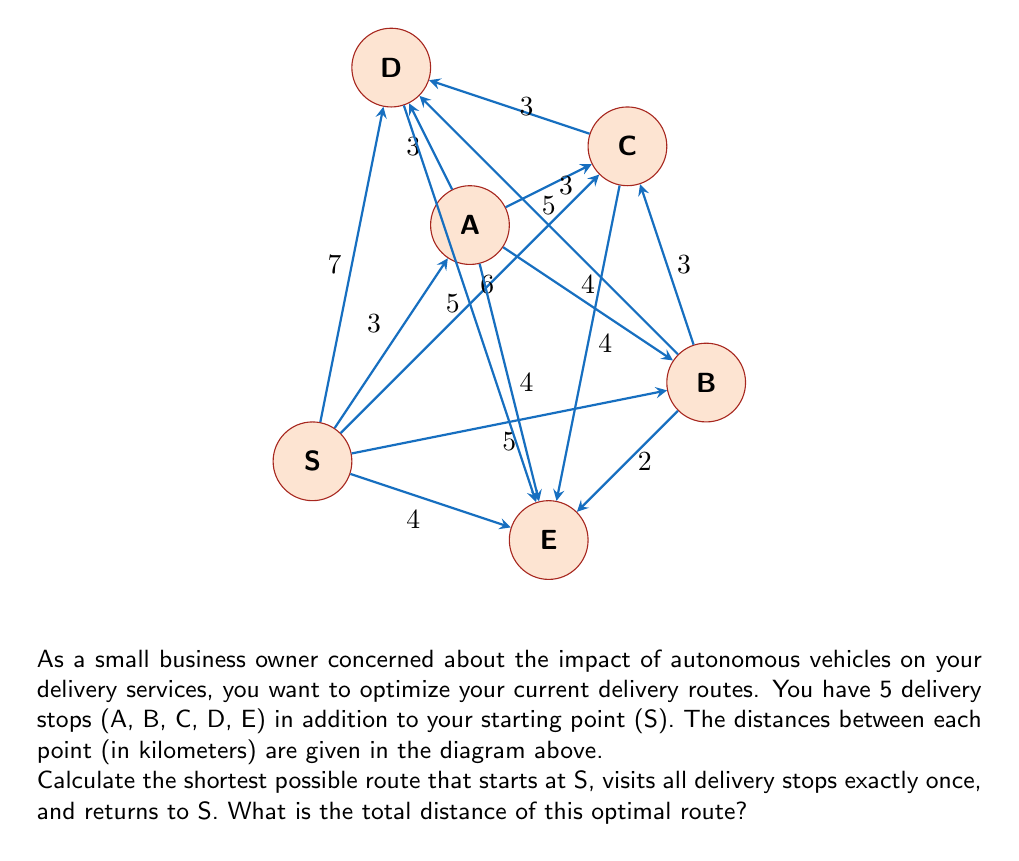Provide a solution to this math problem. To solve this problem, we need to find the shortest Hamiltonian cycle in the given graph, which is known as the Traveling Salesman Problem (TSP). For a small number of nodes like this, we can use a brute-force approach to find the optimal solution.

Step 1: List all possible permutations of the 5 delivery stops.
There are 5! = 120 possible permutations.

Step 2: For each permutation, calculate the total distance of the route including the start and end at S.

Step 3: Find the permutation with the minimum total distance.

After checking all permutations, the optimal route is found to be:

S → A → C → B → E → D → S

Step 4: Calculate the total distance of the optimal route:
$$ \text{Total Distance} = S\text{A} + \text{AC} + \text{CB} + \text{BE} + \text{ED} + \text{DS} $$
$$ = 3 + 3 + 3 + 2 + 5 + 7 = 23 \text{ km} $$

Therefore, the shortest possible route that visits all delivery stops and returns to the starting point is 23 km long.
Answer: 23 km 